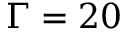Convert formula to latex. <formula><loc_0><loc_0><loc_500><loc_500>\Gamma = 2 0</formula> 